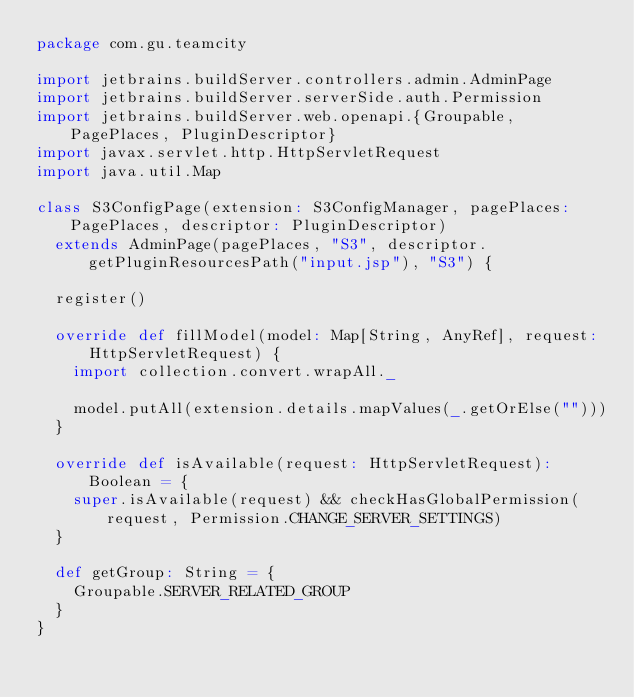<code> <loc_0><loc_0><loc_500><loc_500><_Scala_>package com.gu.teamcity

import jetbrains.buildServer.controllers.admin.AdminPage
import jetbrains.buildServer.serverSide.auth.Permission
import jetbrains.buildServer.web.openapi.{Groupable, PagePlaces, PluginDescriptor}
import javax.servlet.http.HttpServletRequest
import java.util.Map

class S3ConfigPage(extension: S3ConfigManager, pagePlaces: PagePlaces, descriptor: PluginDescriptor)
  extends AdminPage(pagePlaces, "S3", descriptor.getPluginResourcesPath("input.jsp"), "S3") {

  register()

  override def fillModel(model: Map[String, AnyRef], request: HttpServletRequest) {
    import collection.convert.wrapAll._

    model.putAll(extension.details.mapValues(_.getOrElse("")))
  }

  override def isAvailable(request: HttpServletRequest): Boolean = {
    super.isAvailable(request) && checkHasGlobalPermission(request, Permission.CHANGE_SERVER_SETTINGS)
  }

  def getGroup: String = {
    Groupable.SERVER_RELATED_GROUP
  }
}</code> 